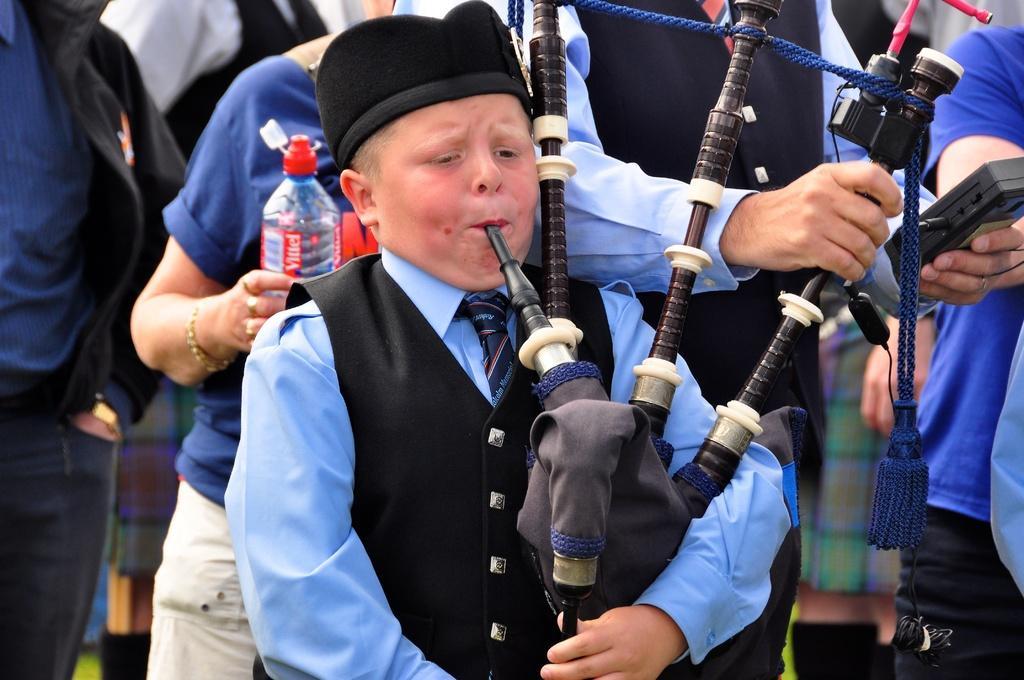Could you give a brief overview of what you see in this image? In this image we can see a person wearing cap. And he is playing a musical instrument. In the back there is a person holding something in the hand. And another person is holding a bottle. In the background there are few people. 